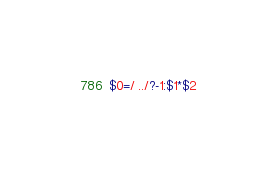Convert code to text. <code><loc_0><loc_0><loc_500><loc_500><_Awk_>$0=/ ../?-1:$1*$2</code> 